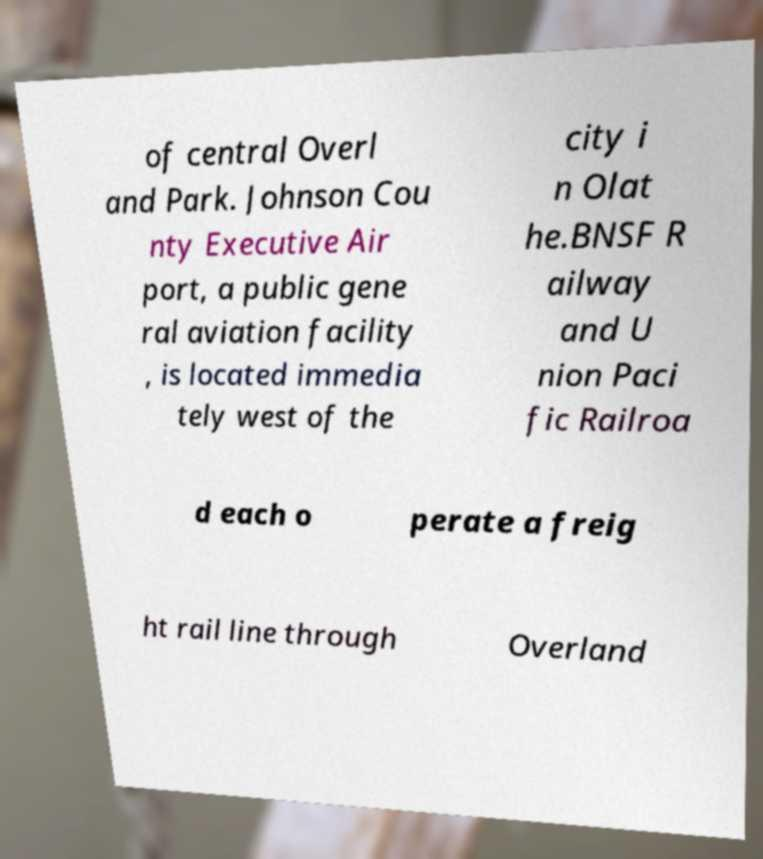Can you accurately transcribe the text from the provided image for me? of central Overl and Park. Johnson Cou nty Executive Air port, a public gene ral aviation facility , is located immedia tely west of the city i n Olat he.BNSF R ailway and U nion Paci fic Railroa d each o perate a freig ht rail line through Overland 